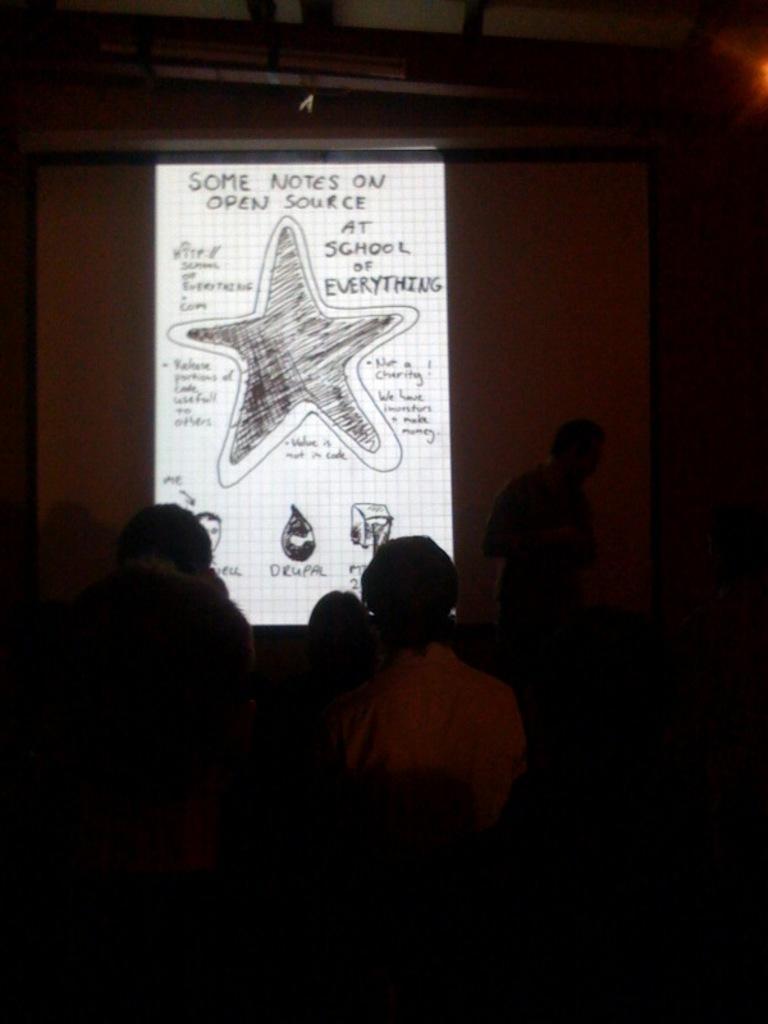Please provide a concise description of this image. At the bottom I can see few people in the dark. In the background there is a screen on which I can see some text. 